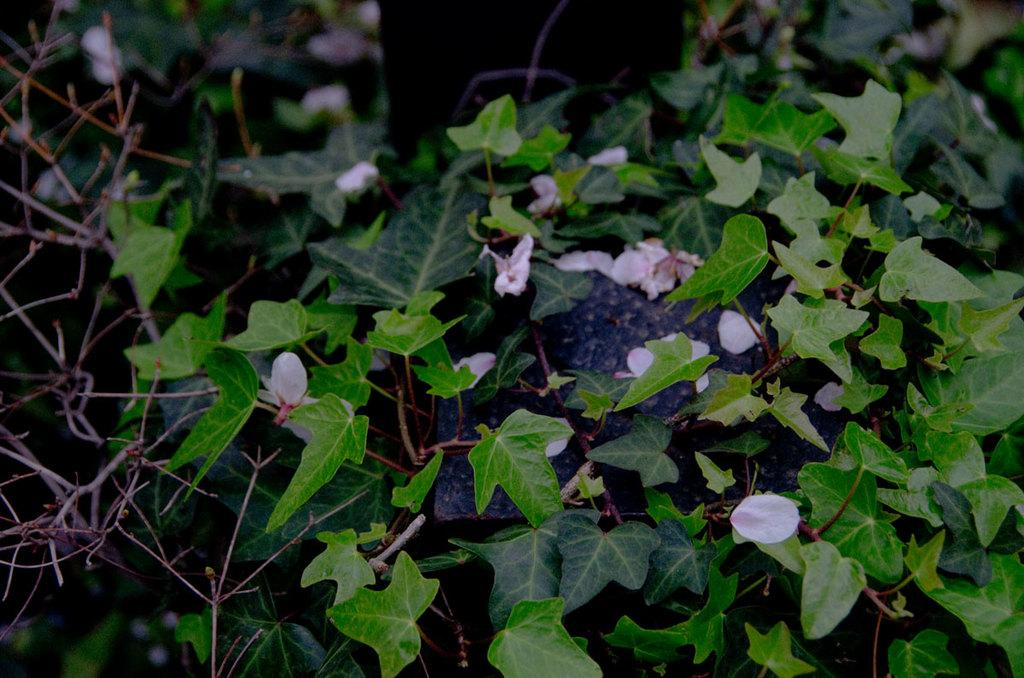What color are the flowers in the image? The flowers in the image are pink. What else can be seen in the image besides the flowers? Leaves and stems are visible in the image. What type of furniture can be seen in the image? There is no furniture present in the image; it features pink flowers, leaves, and stems. What word is written on the leaves in the image? There are no words written on the leaves in the image; it is a natural scene with flowers, leaves, and stems. 